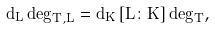<formula> <loc_0><loc_0><loc_500><loc_500>d _ { L } \deg _ { T , L } = d _ { K } \, [ L \colon K ] \deg _ { T } ,</formula> 